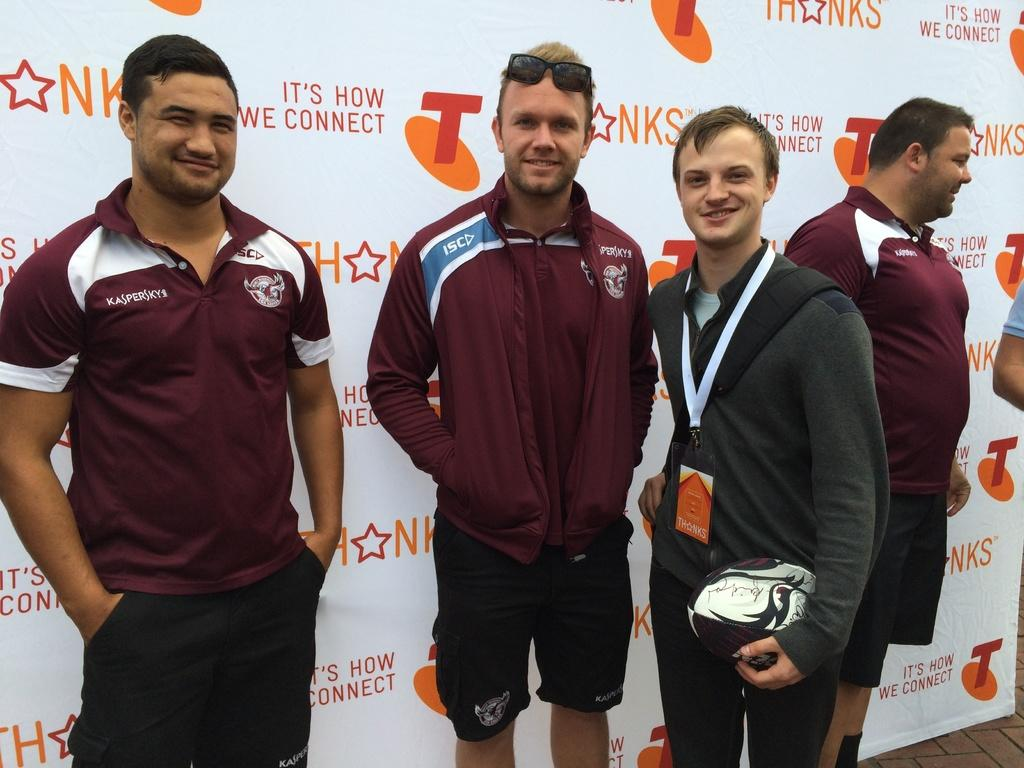<image>
Give a short and clear explanation of the subsequent image. People are posing together in front of a wall that says "it's how we connect." 